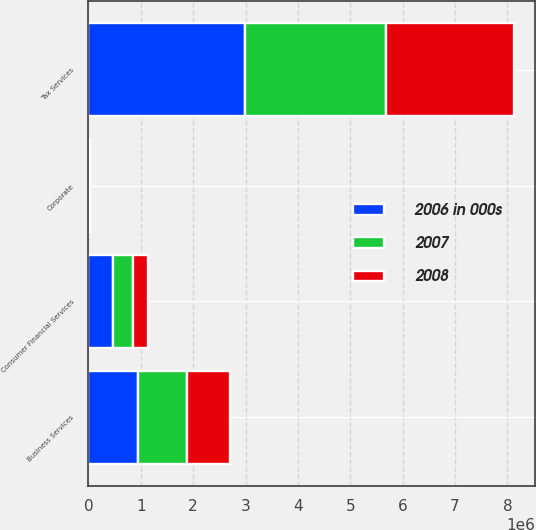<chart> <loc_0><loc_0><loc_500><loc_500><stacked_bar_chart><ecel><fcel>Tax Services<fcel>Business Services<fcel>Consumer Financial Services<fcel>Corporate<nl><fcel>2006 in 000s<fcel>2.98862e+06<fcel>941686<fcel>459953<fcel>13621<nl><fcel>2007<fcel>2.68586e+06<fcel>932361<fcel>388090<fcel>14965<nl><fcel>2008<fcel>2.44975e+06<fcel>828133<fcel>287955<fcel>8914<nl></chart> 